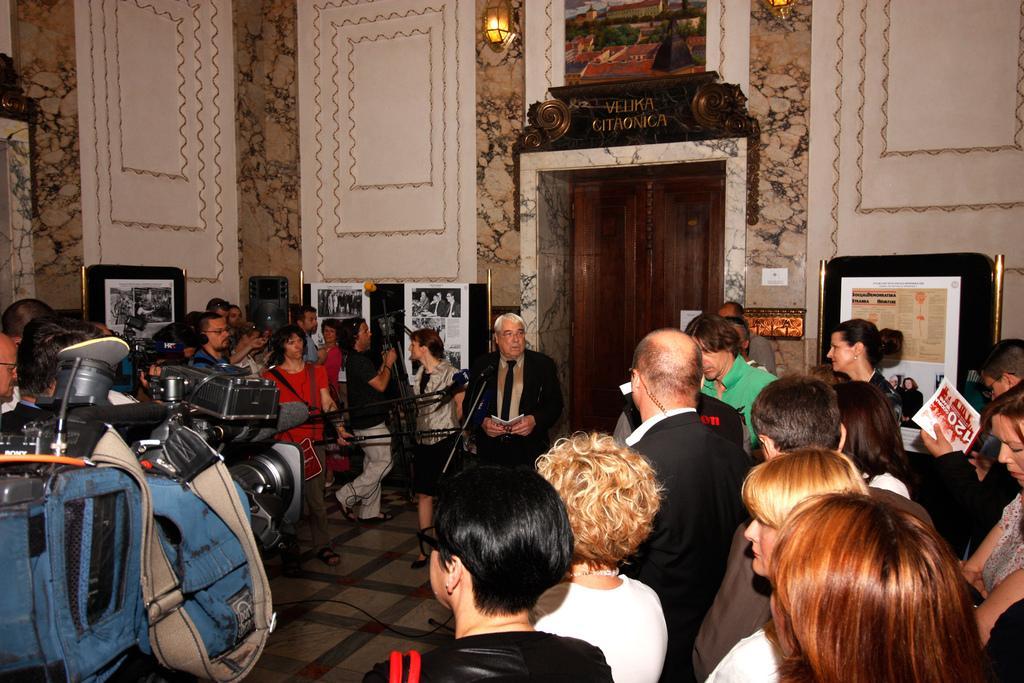Please provide a concise description of this image. On the right side a group of people are standing, in the middle a man is speaking in the microphone he wore a coat, tie shirt. In the middle at the top there is a light on this wall. 